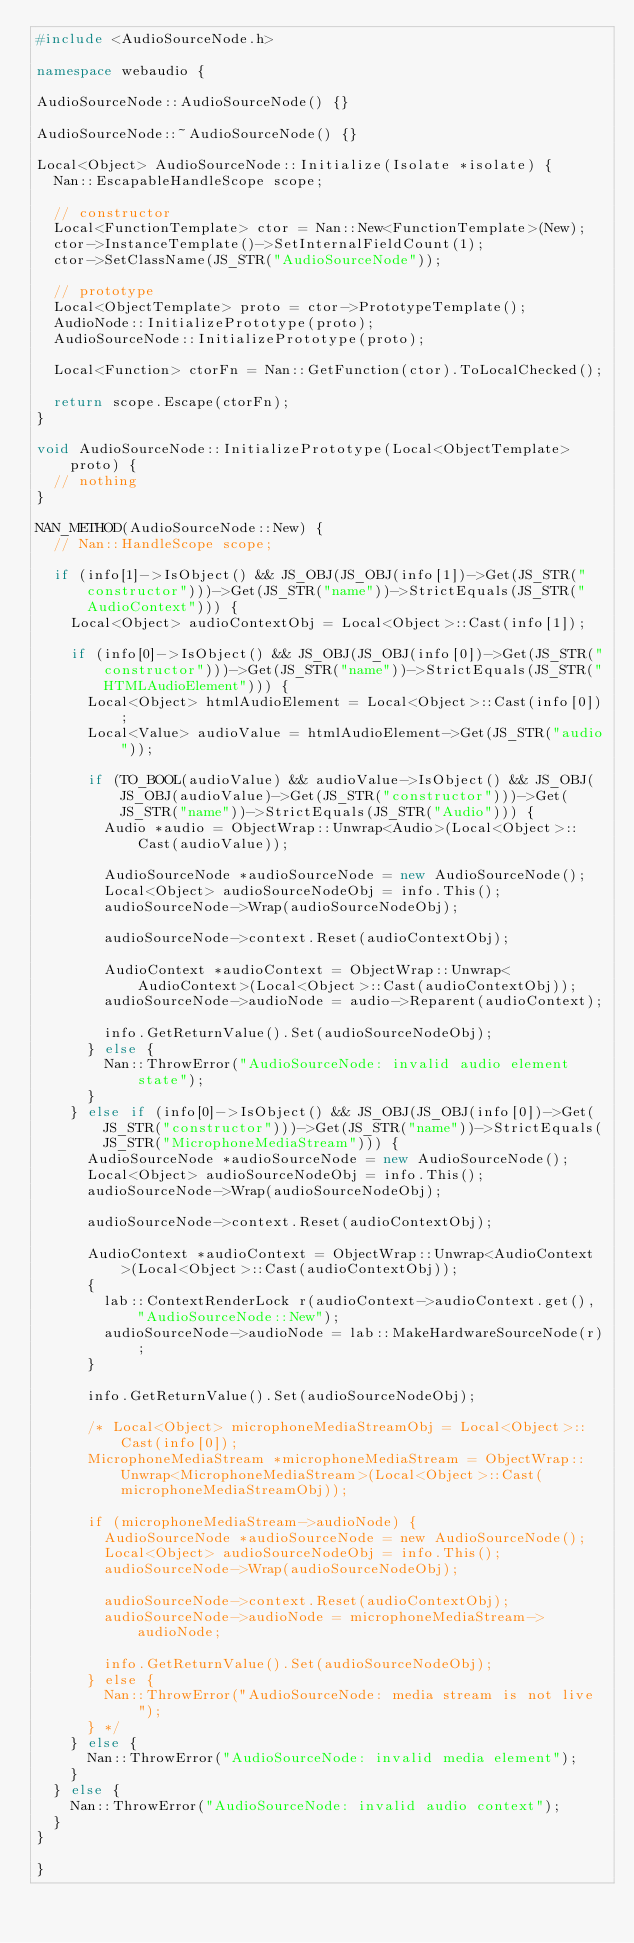Convert code to text. <code><loc_0><loc_0><loc_500><loc_500><_C++_>#include <AudioSourceNode.h>

namespace webaudio {

AudioSourceNode::AudioSourceNode() {}

AudioSourceNode::~AudioSourceNode() {}

Local<Object> AudioSourceNode::Initialize(Isolate *isolate) {
  Nan::EscapableHandleScope scope;

  // constructor
  Local<FunctionTemplate> ctor = Nan::New<FunctionTemplate>(New);
  ctor->InstanceTemplate()->SetInternalFieldCount(1);
  ctor->SetClassName(JS_STR("AudioSourceNode"));

  // prototype
  Local<ObjectTemplate> proto = ctor->PrototypeTemplate();
  AudioNode::InitializePrototype(proto);
  AudioSourceNode::InitializePrototype(proto);

  Local<Function> ctorFn = Nan::GetFunction(ctor).ToLocalChecked();

  return scope.Escape(ctorFn);
}

void AudioSourceNode::InitializePrototype(Local<ObjectTemplate> proto) {
  // nothing
}

NAN_METHOD(AudioSourceNode::New) {
  // Nan::HandleScope scope;

  if (info[1]->IsObject() && JS_OBJ(JS_OBJ(info[1])->Get(JS_STR("constructor")))->Get(JS_STR("name"))->StrictEquals(JS_STR("AudioContext"))) {
    Local<Object> audioContextObj = Local<Object>::Cast(info[1]);

    if (info[0]->IsObject() && JS_OBJ(JS_OBJ(info[0])->Get(JS_STR("constructor")))->Get(JS_STR("name"))->StrictEquals(JS_STR("HTMLAudioElement"))) {
      Local<Object> htmlAudioElement = Local<Object>::Cast(info[0]);
      Local<Value> audioValue = htmlAudioElement->Get(JS_STR("audio"));

      if (TO_BOOL(audioValue) && audioValue->IsObject() && JS_OBJ(JS_OBJ(audioValue)->Get(JS_STR("constructor")))->Get(JS_STR("name"))->StrictEquals(JS_STR("Audio"))) {
        Audio *audio = ObjectWrap::Unwrap<Audio>(Local<Object>::Cast(audioValue));

        AudioSourceNode *audioSourceNode = new AudioSourceNode();
        Local<Object> audioSourceNodeObj = info.This();
        audioSourceNode->Wrap(audioSourceNodeObj);

        audioSourceNode->context.Reset(audioContextObj);
        
        AudioContext *audioContext = ObjectWrap::Unwrap<AudioContext>(Local<Object>::Cast(audioContextObj));
        audioSourceNode->audioNode = audio->Reparent(audioContext);

        info.GetReturnValue().Set(audioSourceNodeObj);
      } else {
        Nan::ThrowError("AudioSourceNode: invalid audio element state");
      }
    } else if (info[0]->IsObject() && JS_OBJ(JS_OBJ(info[0])->Get(JS_STR("constructor")))->Get(JS_STR("name"))->StrictEquals(JS_STR("MicrophoneMediaStream"))) {
      AudioSourceNode *audioSourceNode = new AudioSourceNode();
      Local<Object> audioSourceNodeObj = info.This();
      audioSourceNode->Wrap(audioSourceNodeObj);
      
      audioSourceNode->context.Reset(audioContextObj);
  
      AudioContext *audioContext = ObjectWrap::Unwrap<AudioContext>(Local<Object>::Cast(audioContextObj));
      {
        lab::ContextRenderLock r(audioContext->audioContext.get(), "AudioSourceNode::New");
        audioSourceNode->audioNode = lab::MakeHardwareSourceNode(r);
      }
      
      info.GetReturnValue().Set(audioSourceNodeObj);

      /* Local<Object> microphoneMediaStreamObj = Local<Object>::Cast(info[0]);
      MicrophoneMediaStream *microphoneMediaStream = ObjectWrap::Unwrap<MicrophoneMediaStream>(Local<Object>::Cast(microphoneMediaStreamObj));

      if (microphoneMediaStream->audioNode) {
        AudioSourceNode *audioSourceNode = new AudioSourceNode();
        Local<Object> audioSourceNodeObj = info.This();
        audioSourceNode->Wrap(audioSourceNodeObj);

        audioSourceNode->context.Reset(audioContextObj);
        audioSourceNode->audioNode = microphoneMediaStream->audioNode;

        info.GetReturnValue().Set(audioSourceNodeObj);
      } else {
        Nan::ThrowError("AudioSourceNode: media stream is not live");
      } */
    } else {
      Nan::ThrowError("AudioSourceNode: invalid media element");
    }
  } else {
    Nan::ThrowError("AudioSourceNode: invalid audio context");
  }
}

}
</code> 